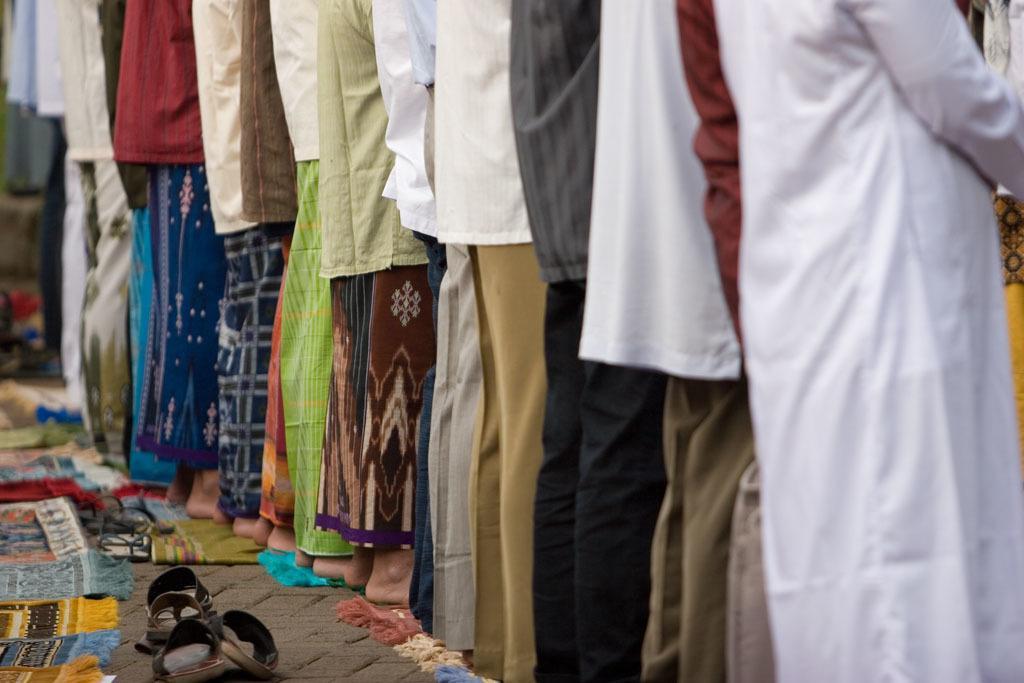Please provide a concise description of this image. In this image there are few man standing in a line, behind them there are slippers. 